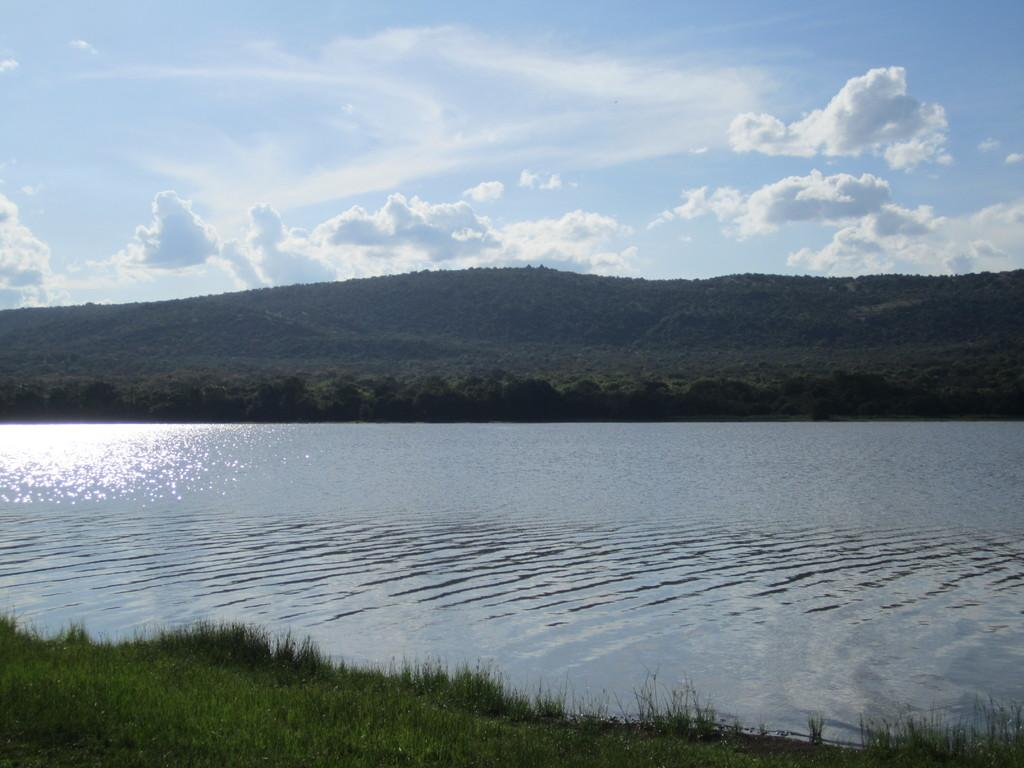What body of water is present in the image? There is a lake in the image. What type of vegetation is near the lake? There is grass beside the lake. What can be seen in the background of the image? There is a group of trees and a hill visible in the background. How would you describe the sky in the image? The sky is visible and appears cloudy. Where are the sheep grazing in the image? There are no sheep present in the image. What sound does the bell make in the image? There is no bell present in the image. 